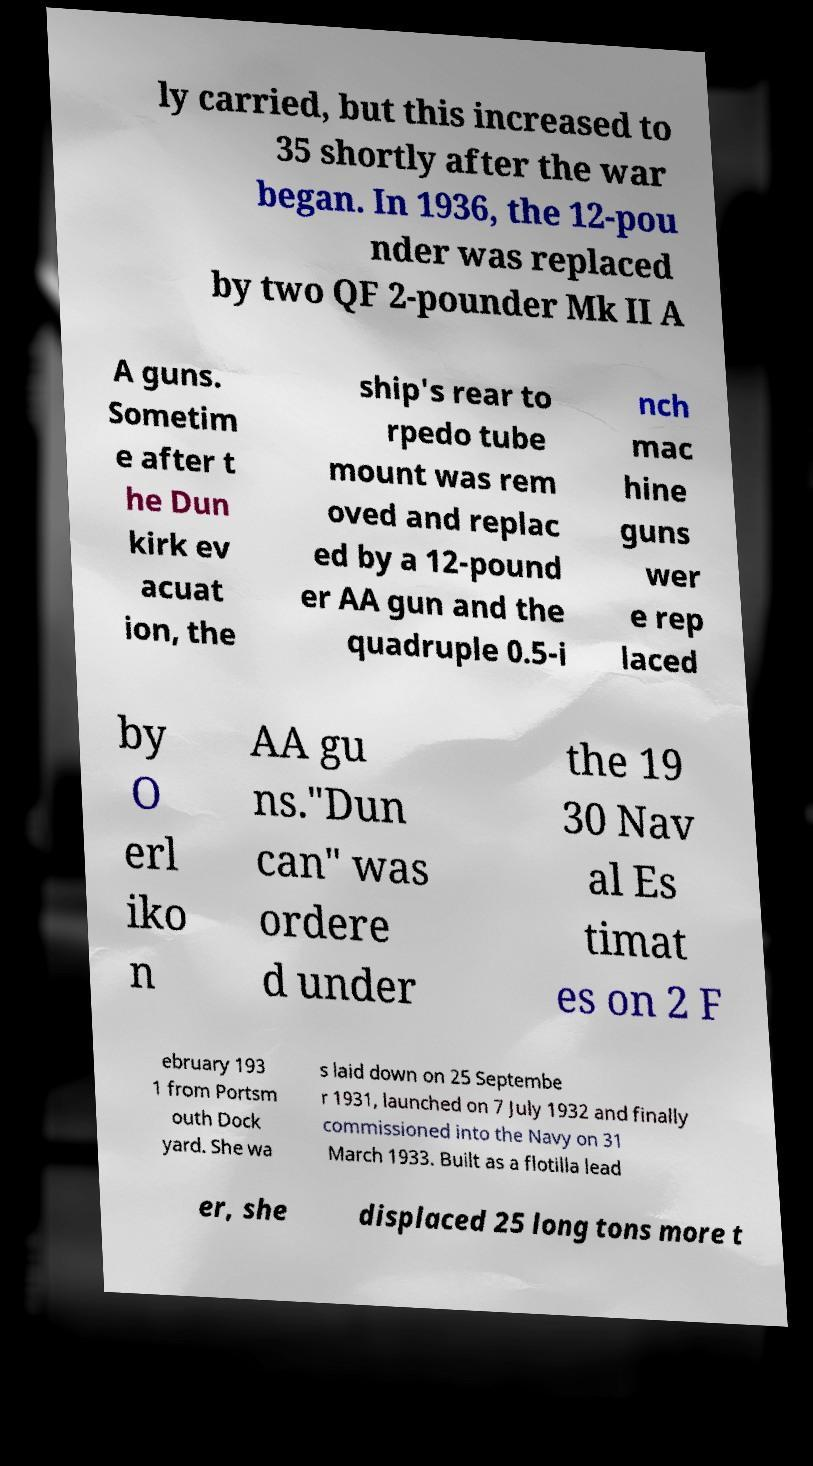For documentation purposes, I need the text within this image transcribed. Could you provide that? ly carried, but this increased to 35 shortly after the war began. In 1936, the 12-pou nder was replaced by two QF 2-pounder Mk II A A guns. Sometim e after t he Dun kirk ev acuat ion, the ship's rear to rpedo tube mount was rem oved and replac ed by a 12-pound er AA gun and the quadruple 0.5-i nch mac hine guns wer e rep laced by O erl iko n AA gu ns."Dun can" was ordere d under the 19 30 Nav al Es timat es on 2 F ebruary 193 1 from Portsm outh Dock yard. She wa s laid down on 25 Septembe r 1931, launched on 7 July 1932 and finally commissioned into the Navy on 31 March 1933. Built as a flotilla lead er, she displaced 25 long tons more t 